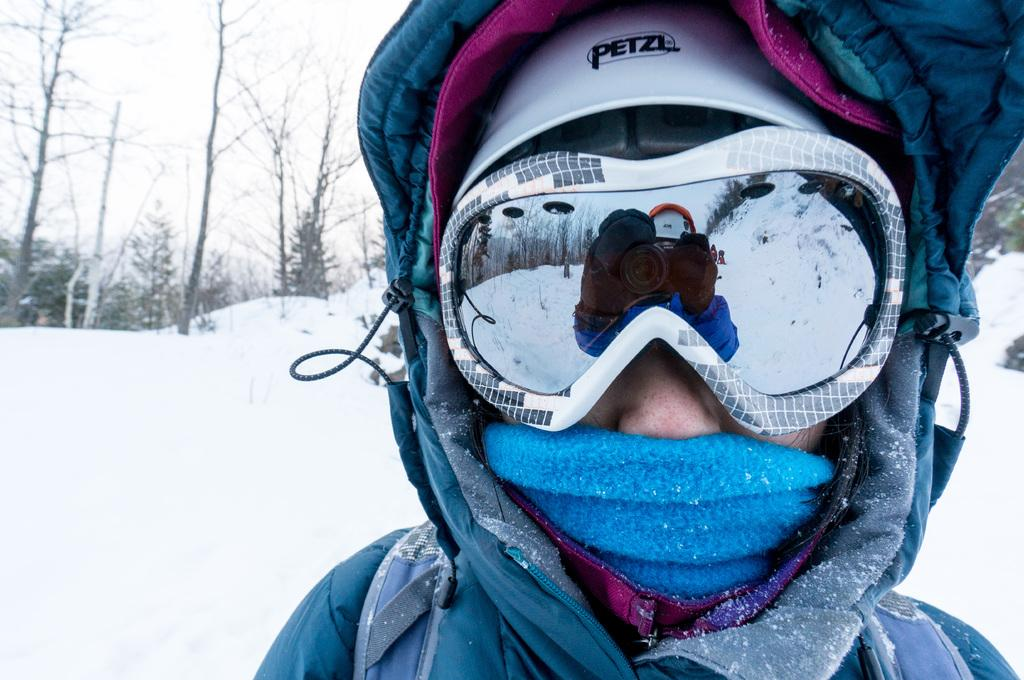Who is present in the image? There is a man in the image. What is the man wearing? The man is wearing a sweater and diving glasses. What can be seen in the background of the image? There is snow and trees in the background of the image. What type of clouds can be seen in the image? There are no clouds visible in the image; it features a man wearing a sweater and diving glasses, with snow and trees in the background. What kind of party is happening in the image? There is no party depicted in the image. 